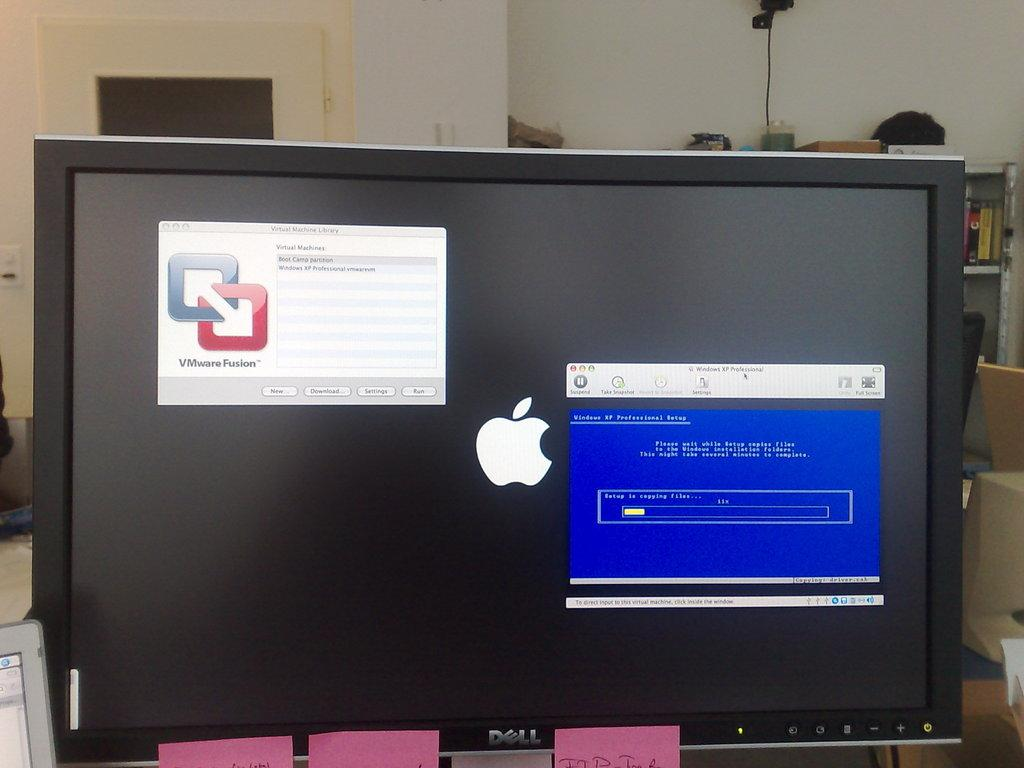<image>
Present a compact description of the photo's key features. a dell computer screen with the apple symbol on the screen 